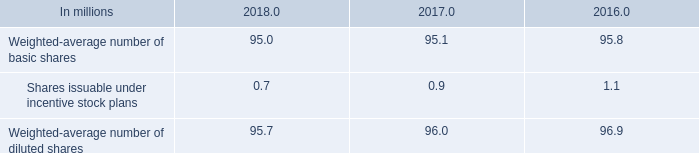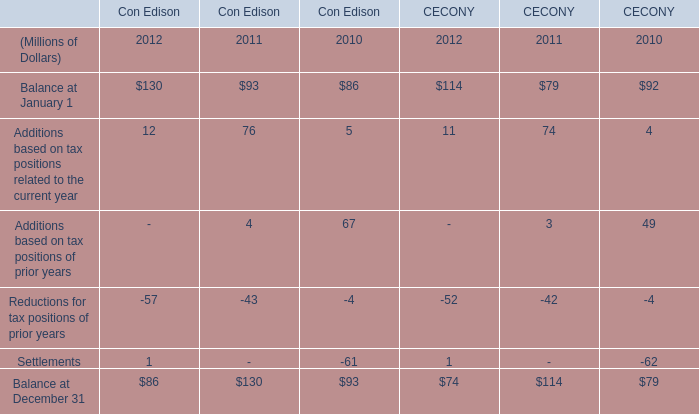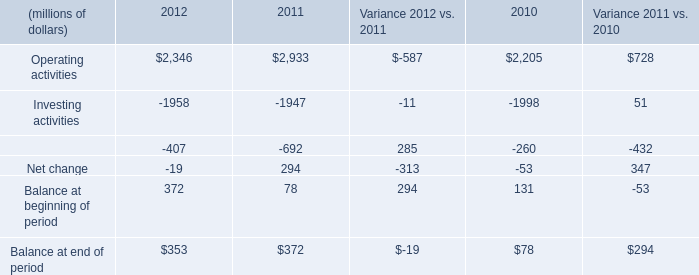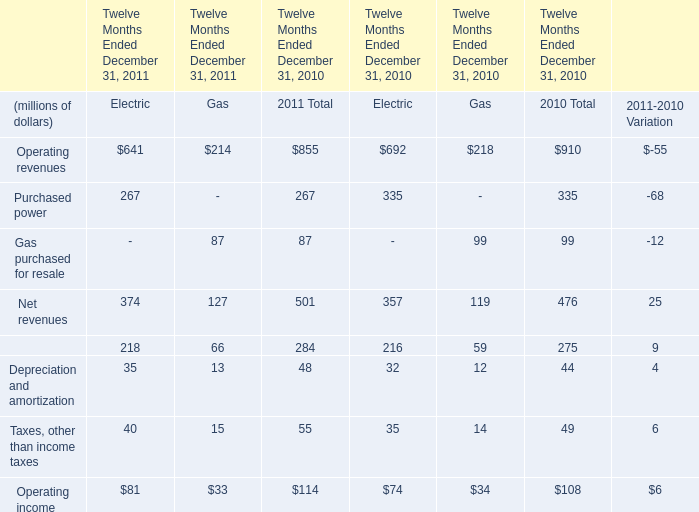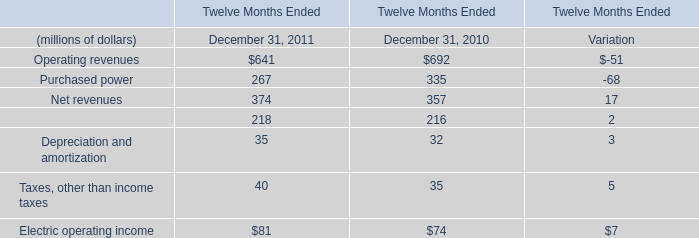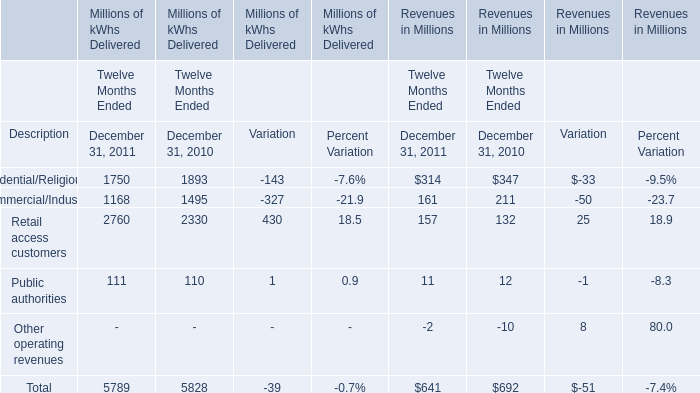How many elements' value in 2011 are lower than the previous year ? 
Answer: 2. 